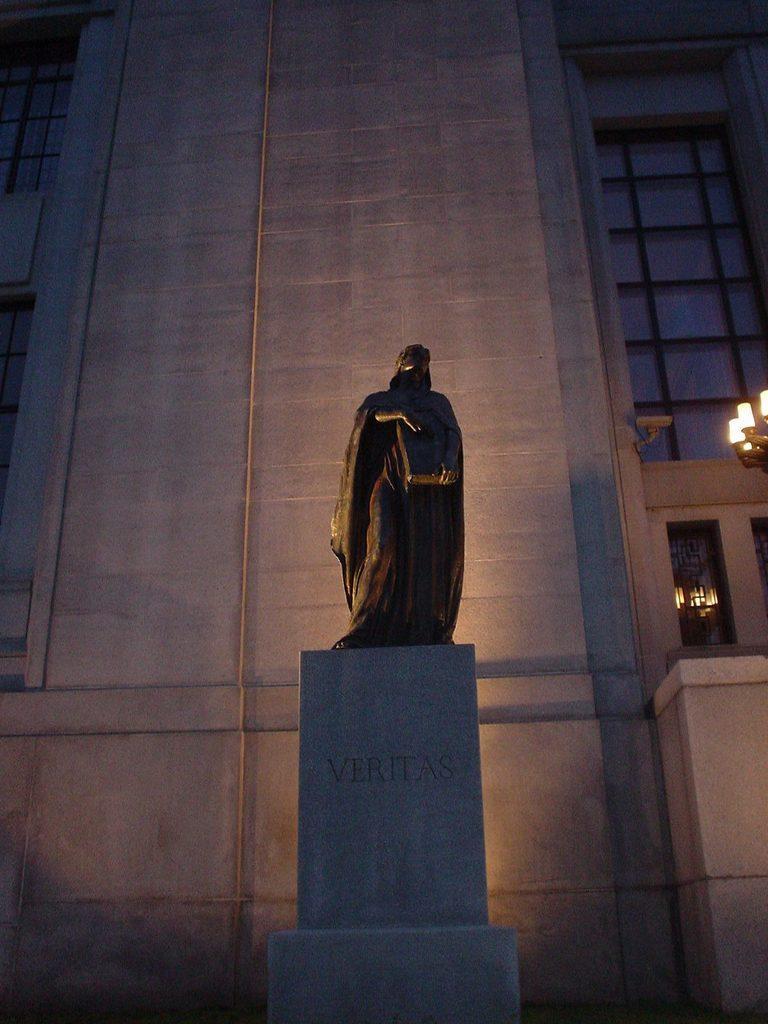Please provide a concise description of this image. This image consists of a building. It has windows. 